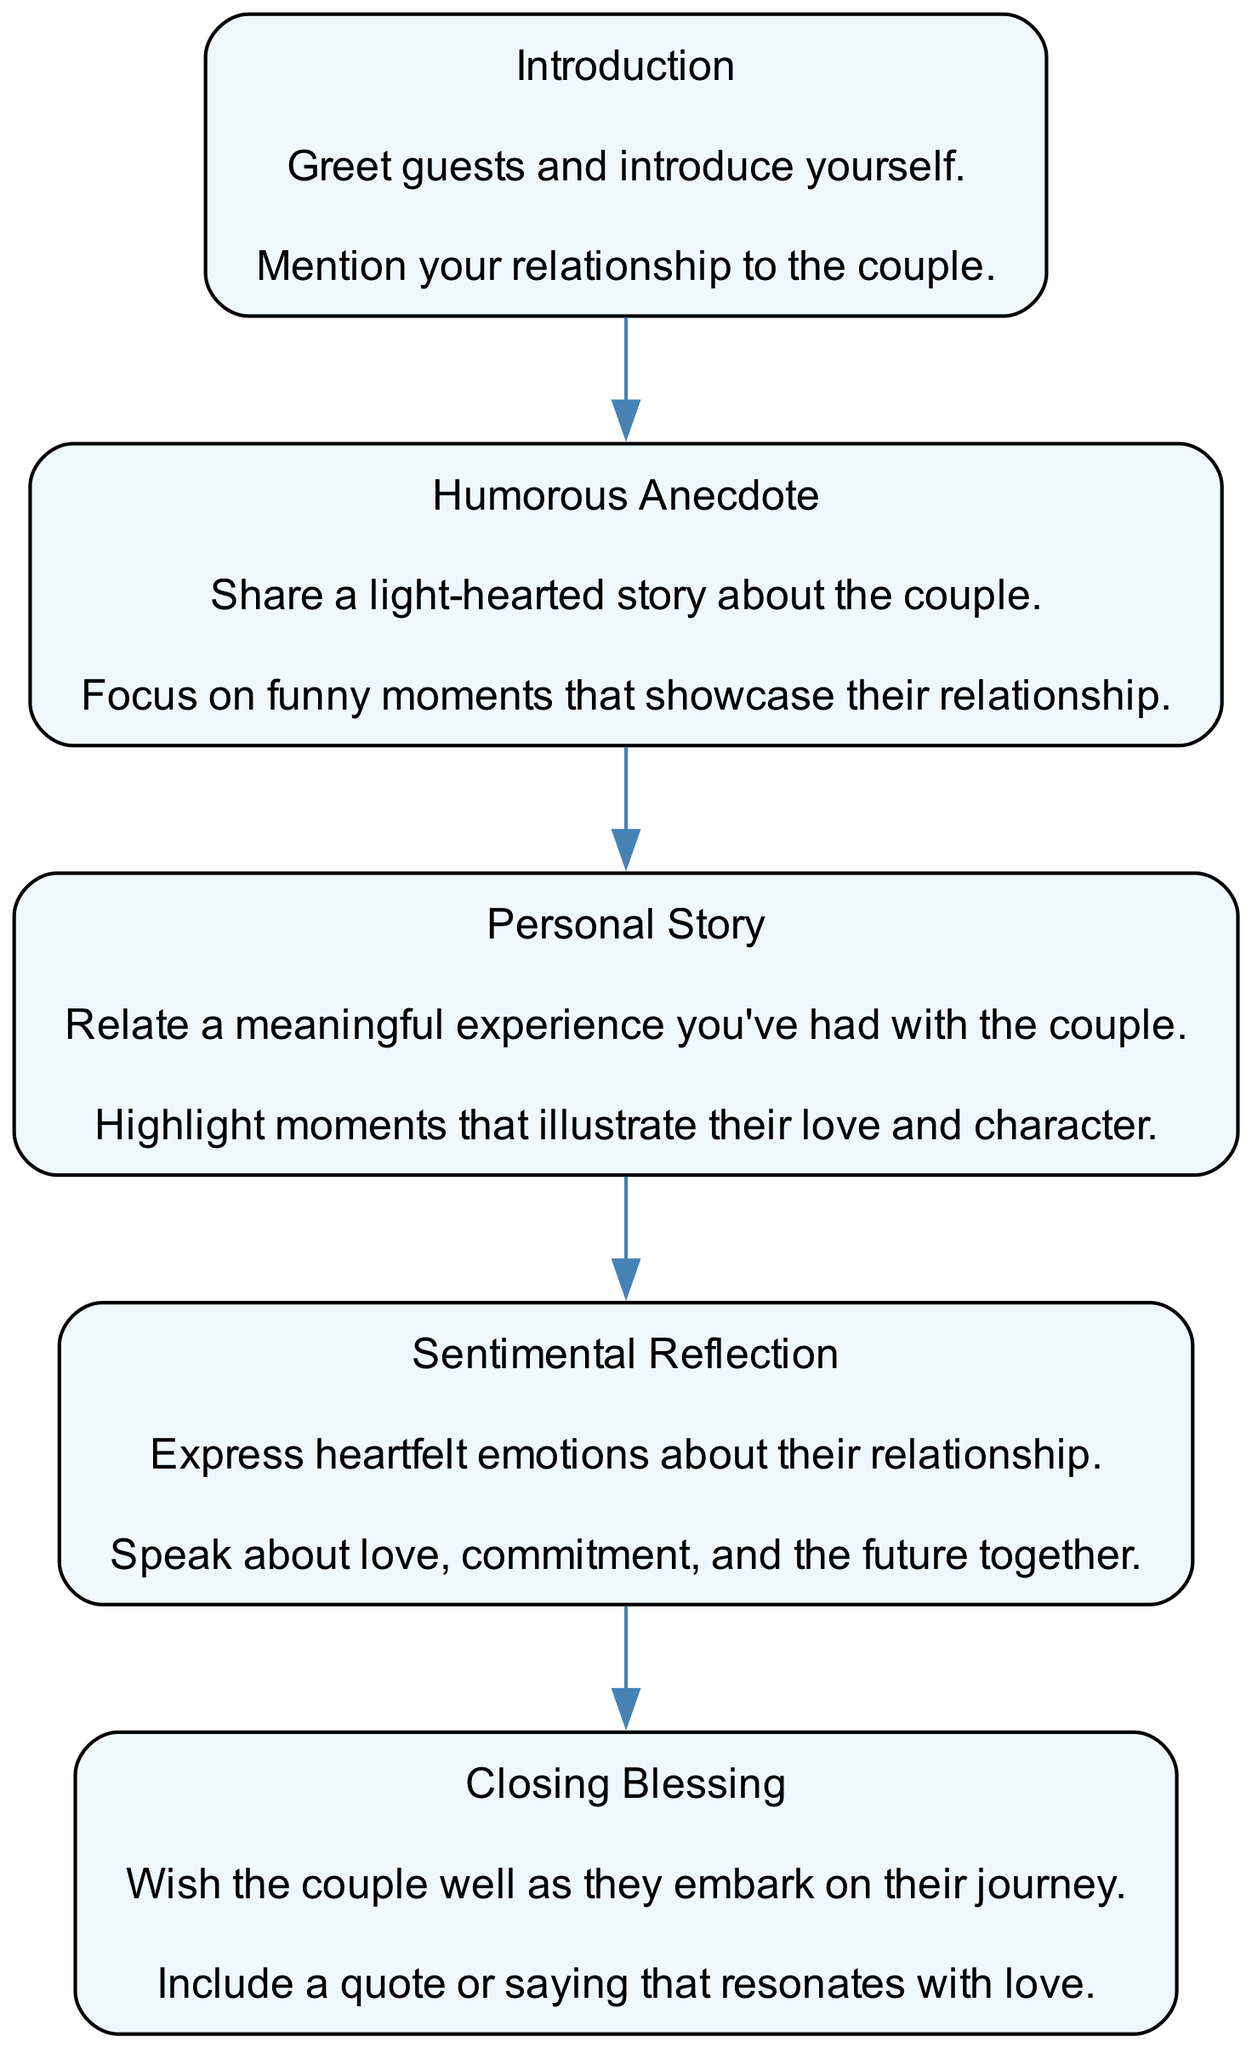what is the first step in the template? The first step outlined in the template is "Introduction," which includes greeting the guests and introducing oneself, mentioning the relationship to the couple.
Answer: Introduction how many steps are there in the flow chart? The flow chart has a total of five steps, including Introduction, Humorous Anecdote, Personal Story, Sentimental Reflection, and Closing Blessing.
Answer: Five what is shared in the "Humorous Anecdote" step? In the "Humorous Anecdote" step, a light-hearted story is shared about the couple, specifically focusing on funny moments that showcase their relationship.
Answer: A light-hearted story about the couple what emotion is expressed in the "Sentimental Reflection" step? The "Sentimental Reflection" step involves expressing heartfelt emotions about love, commitment, and the couple's future together.
Answer: Heartfelt emotions what is the final step in the template? The final step in the template is "Closing Blessing," which wishes the couple well as they embark on their journey and includes a resonant quote or saying about love.
Answer: Closing Blessing what relationship is mentioned in the "Introduction" step? In the "Introduction" step, the speaker mentions their relationship to the couple, establishing a connection with the audience.
Answer: Relationship to the couple which step illustrates moments that highlight love and character? The "Personal Story" step illustrates meaningful experiences that highlight moments related to the couple's love and character.
Answer: Personal Story how does the "Sentimental Reflection" step relate to the "Closing Blessing"? The "Sentimental Reflection" step sets the emotional tone by discussing deep feelings about the couple's commitment, which naturally leads into the "Closing Blessing," wishing them well in their journey together.
Answer: It sets the emotional tone for the blessing 